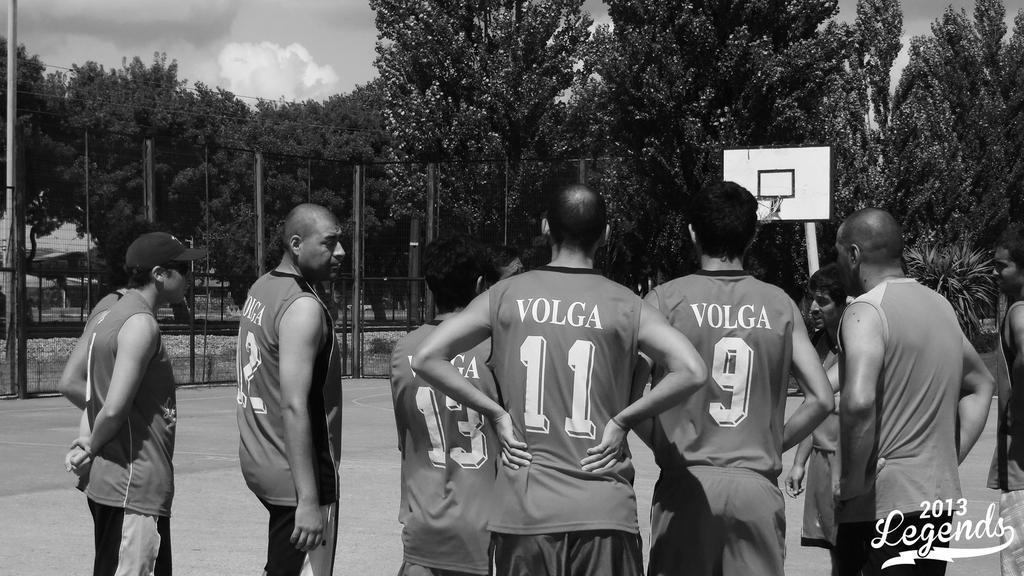How would you summarize this image in a sentence or two? In this picture we can observe some basketball players standing in the court. All of them were men. In the background we can observe a basketball net. There is a fence. In the background there are trees and a sky with clouds. 